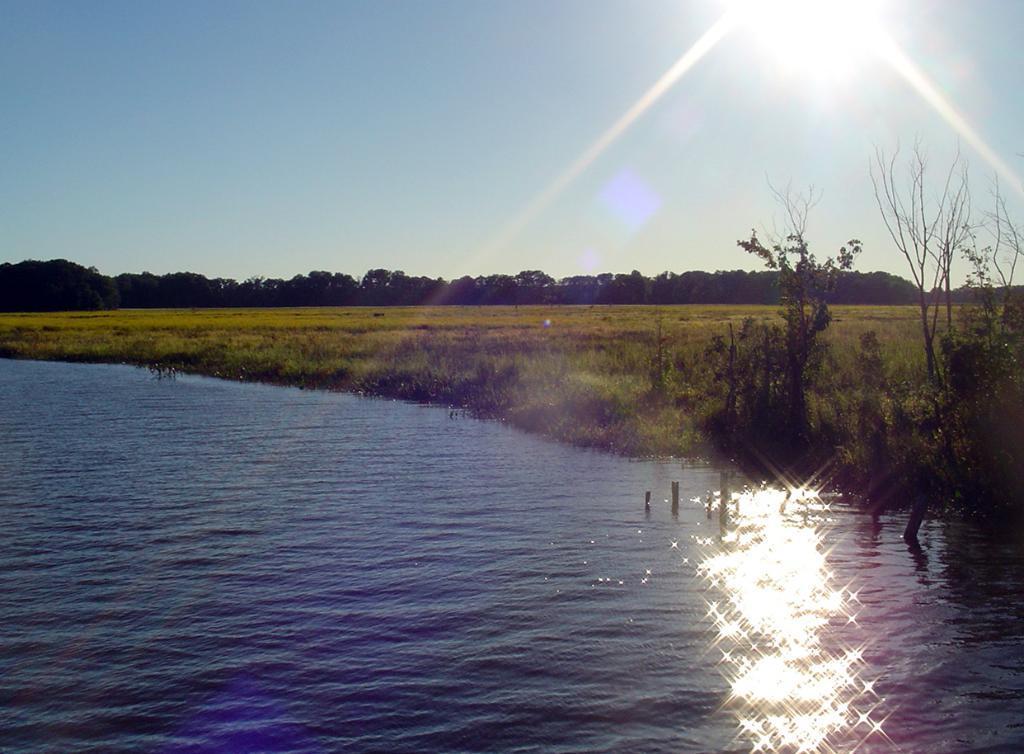How would you summarize this image in a sentence or two? In this picture I can see the water in front and in the middle of this picture I see the plants and the grass. In the background I see the trees and the sky and on the top of this image I see the sun. 